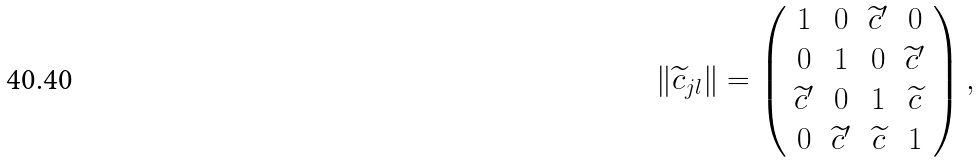Convert formula to latex. <formula><loc_0><loc_0><loc_500><loc_500>\| \widetilde { c } _ { j l } \| = \left ( \begin{array} { c c c c } 1 & 0 & \widetilde { c } ^ { \prime } & 0 \\ 0 & 1 & 0 & \widetilde { c } ^ { \prime } \\ \widetilde { c } ^ { \prime } & 0 & 1 & \widetilde { c } \\ 0 & \widetilde { c } ^ { \prime } & \widetilde { c } & 1 \end{array} \right ) ,</formula> 